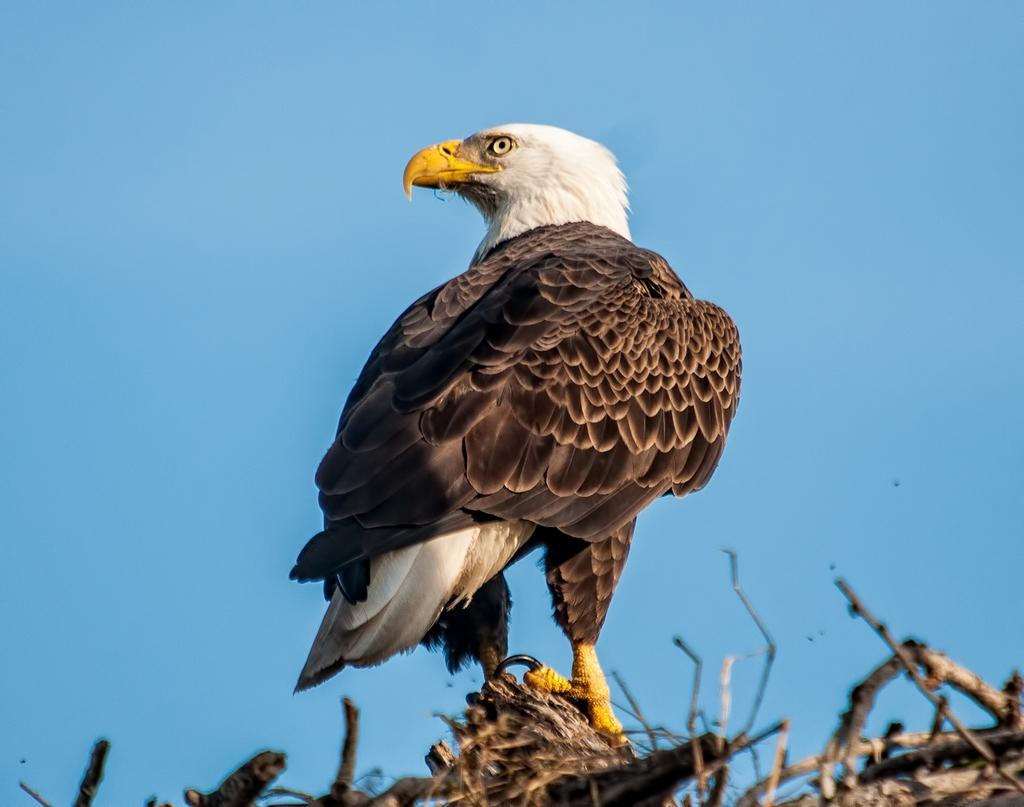What type of animal can be seen in the image? There is a bird in the image. What is located at the bottom of the image? There are pieces of wood at the bottom of the image. What part of the natural environment is visible in the image? The sky is visible in the image. What type of bag is the bird carrying on its wrist in the image? There is no bag or wrist present in the image; it features a bird and pieces of wood. 